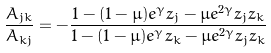Convert formula to latex. <formula><loc_0><loc_0><loc_500><loc_500>\frac { A _ { j k } } { A _ { k j } } = - \frac { 1 - ( 1 - \mu ) e ^ { \gamma } z _ { j } - \mu e ^ { 2 \gamma } z _ { j } z _ { k } } { 1 - ( 1 - \mu ) e ^ { \gamma } z _ { k } - \mu e ^ { 2 \gamma } z _ { j } z _ { k } }</formula> 